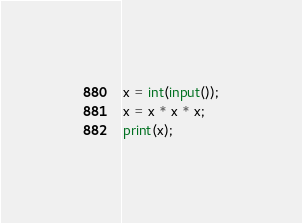<code> <loc_0><loc_0><loc_500><loc_500><_Python_>x = int(input());
x = x * x * x;
print(x);
</code> 